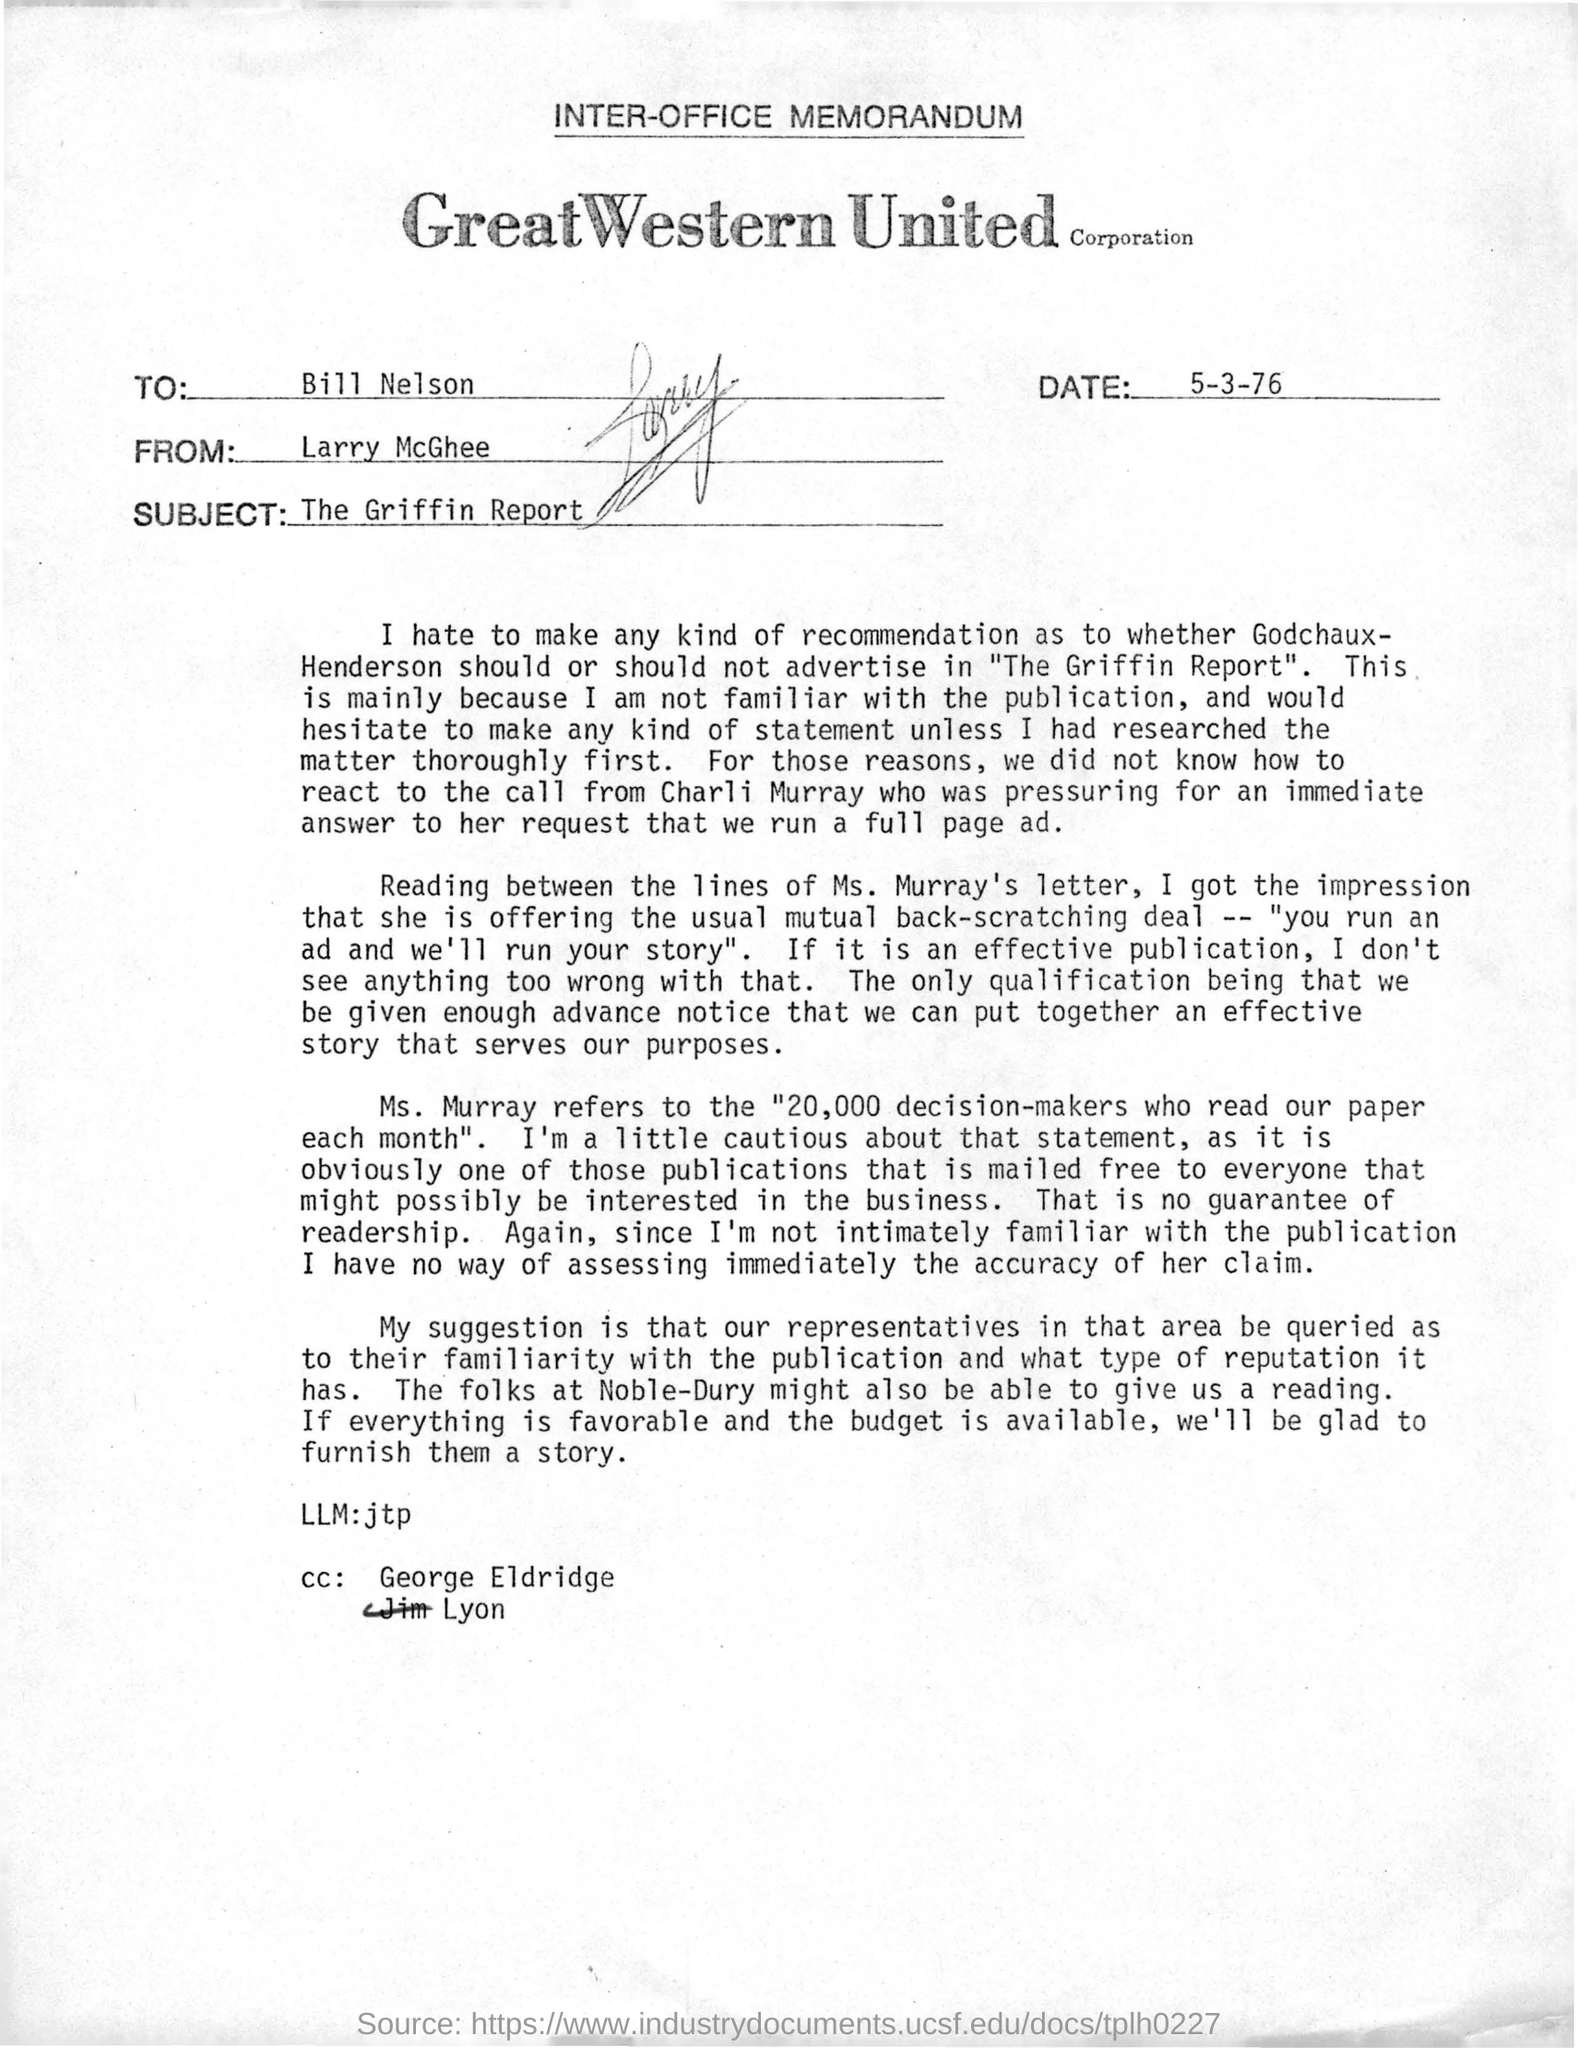Identify some key points in this picture. The subject of this memorandum is the Griffin Report. The memorandum is from Larry McGhee. The recipient of the memorandum is Bill Nelson. The memorandum in question provides the date of March 5th, 1976. 